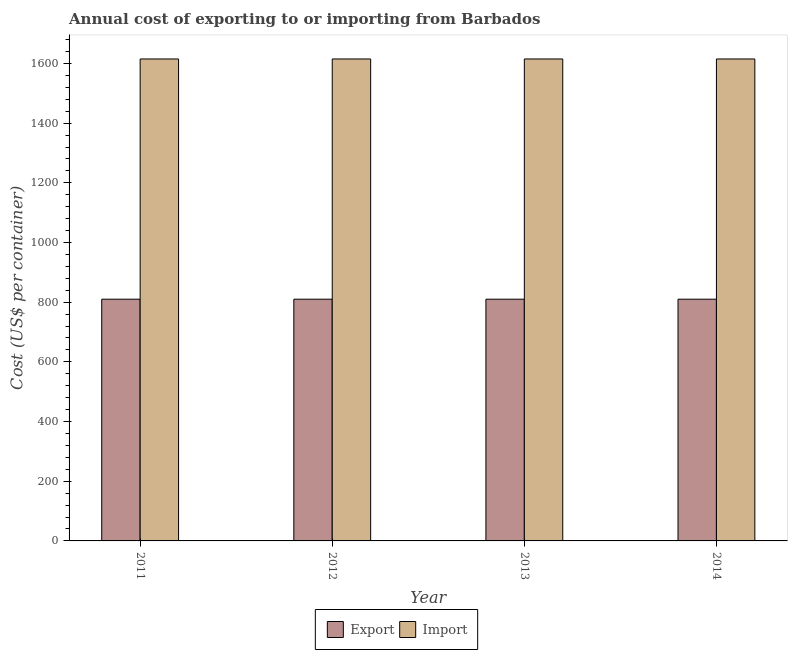How many different coloured bars are there?
Your answer should be compact. 2. How many groups of bars are there?
Offer a terse response. 4. Are the number of bars on each tick of the X-axis equal?
Give a very brief answer. Yes. How many bars are there on the 1st tick from the left?
Your response must be concise. 2. What is the export cost in 2012?
Ensure brevity in your answer.  810. Across all years, what is the maximum import cost?
Provide a succinct answer. 1615. Across all years, what is the minimum import cost?
Ensure brevity in your answer.  1615. What is the total export cost in the graph?
Ensure brevity in your answer.  3240. What is the difference between the export cost in 2011 and that in 2012?
Give a very brief answer. 0. What is the difference between the export cost in 2012 and the import cost in 2014?
Your answer should be compact. 0. What is the average export cost per year?
Your response must be concise. 810. In how many years, is the export cost greater than 960 US$?
Your answer should be very brief. 0. Is the export cost in 2011 less than that in 2013?
Make the answer very short. No. What is the difference between the highest and the second highest export cost?
Your answer should be very brief. 0. What is the difference between the highest and the lowest import cost?
Your response must be concise. 0. Is the sum of the export cost in 2011 and 2014 greater than the maximum import cost across all years?
Your answer should be compact. Yes. What does the 1st bar from the left in 2011 represents?
Provide a short and direct response. Export. What does the 1st bar from the right in 2012 represents?
Give a very brief answer. Import. How many bars are there?
Offer a terse response. 8. Are all the bars in the graph horizontal?
Offer a very short reply. No. What is the difference between two consecutive major ticks on the Y-axis?
Ensure brevity in your answer.  200. Are the values on the major ticks of Y-axis written in scientific E-notation?
Give a very brief answer. No. Does the graph contain any zero values?
Offer a terse response. No. Does the graph contain grids?
Your response must be concise. No. What is the title of the graph?
Ensure brevity in your answer.  Annual cost of exporting to or importing from Barbados. Does "Public funds" appear as one of the legend labels in the graph?
Give a very brief answer. No. What is the label or title of the Y-axis?
Provide a short and direct response. Cost (US$ per container). What is the Cost (US$ per container) of Export in 2011?
Provide a short and direct response. 810. What is the Cost (US$ per container) of Import in 2011?
Offer a very short reply. 1615. What is the Cost (US$ per container) of Export in 2012?
Make the answer very short. 810. What is the Cost (US$ per container) in Import in 2012?
Make the answer very short. 1615. What is the Cost (US$ per container) in Export in 2013?
Your response must be concise. 810. What is the Cost (US$ per container) of Import in 2013?
Provide a short and direct response. 1615. What is the Cost (US$ per container) of Export in 2014?
Your answer should be very brief. 810. What is the Cost (US$ per container) in Import in 2014?
Keep it short and to the point. 1615. Across all years, what is the maximum Cost (US$ per container) of Export?
Keep it short and to the point. 810. Across all years, what is the maximum Cost (US$ per container) of Import?
Make the answer very short. 1615. Across all years, what is the minimum Cost (US$ per container) of Export?
Your response must be concise. 810. Across all years, what is the minimum Cost (US$ per container) of Import?
Give a very brief answer. 1615. What is the total Cost (US$ per container) of Export in the graph?
Make the answer very short. 3240. What is the total Cost (US$ per container) in Import in the graph?
Your answer should be very brief. 6460. What is the difference between the Cost (US$ per container) in Export in 2011 and that in 2013?
Offer a very short reply. 0. What is the difference between the Cost (US$ per container) in Import in 2011 and that in 2013?
Provide a short and direct response. 0. What is the difference between the Cost (US$ per container) in Import in 2011 and that in 2014?
Make the answer very short. 0. What is the difference between the Cost (US$ per container) of Import in 2012 and that in 2013?
Ensure brevity in your answer.  0. What is the difference between the Cost (US$ per container) in Export in 2012 and that in 2014?
Keep it short and to the point. 0. What is the difference between the Cost (US$ per container) of Import in 2012 and that in 2014?
Your answer should be very brief. 0. What is the difference between the Cost (US$ per container) in Export in 2011 and the Cost (US$ per container) in Import in 2012?
Your answer should be very brief. -805. What is the difference between the Cost (US$ per container) in Export in 2011 and the Cost (US$ per container) in Import in 2013?
Ensure brevity in your answer.  -805. What is the difference between the Cost (US$ per container) in Export in 2011 and the Cost (US$ per container) in Import in 2014?
Your answer should be compact. -805. What is the difference between the Cost (US$ per container) of Export in 2012 and the Cost (US$ per container) of Import in 2013?
Your answer should be compact. -805. What is the difference between the Cost (US$ per container) of Export in 2012 and the Cost (US$ per container) of Import in 2014?
Your response must be concise. -805. What is the difference between the Cost (US$ per container) in Export in 2013 and the Cost (US$ per container) in Import in 2014?
Offer a terse response. -805. What is the average Cost (US$ per container) in Export per year?
Your response must be concise. 810. What is the average Cost (US$ per container) of Import per year?
Provide a short and direct response. 1615. In the year 2011, what is the difference between the Cost (US$ per container) of Export and Cost (US$ per container) of Import?
Give a very brief answer. -805. In the year 2012, what is the difference between the Cost (US$ per container) of Export and Cost (US$ per container) of Import?
Make the answer very short. -805. In the year 2013, what is the difference between the Cost (US$ per container) of Export and Cost (US$ per container) of Import?
Keep it short and to the point. -805. In the year 2014, what is the difference between the Cost (US$ per container) in Export and Cost (US$ per container) in Import?
Provide a short and direct response. -805. What is the ratio of the Cost (US$ per container) of Export in 2011 to that in 2012?
Ensure brevity in your answer.  1. What is the ratio of the Cost (US$ per container) of Import in 2011 to that in 2012?
Provide a succinct answer. 1. What is the ratio of the Cost (US$ per container) in Export in 2011 to that in 2013?
Offer a very short reply. 1. What is the ratio of the Cost (US$ per container) in Import in 2011 to that in 2013?
Make the answer very short. 1. What is the ratio of the Cost (US$ per container) in Export in 2011 to that in 2014?
Make the answer very short. 1. What is the ratio of the Cost (US$ per container) of Export in 2012 to that in 2013?
Your answer should be very brief. 1. What is the ratio of the Cost (US$ per container) of Export in 2012 to that in 2014?
Your answer should be very brief. 1. What is the ratio of the Cost (US$ per container) of Export in 2013 to that in 2014?
Give a very brief answer. 1. What is the ratio of the Cost (US$ per container) of Import in 2013 to that in 2014?
Keep it short and to the point. 1. What is the difference between the highest and the second highest Cost (US$ per container) in Import?
Ensure brevity in your answer.  0. What is the difference between the highest and the lowest Cost (US$ per container) in Export?
Ensure brevity in your answer.  0. What is the difference between the highest and the lowest Cost (US$ per container) in Import?
Your answer should be very brief. 0. 